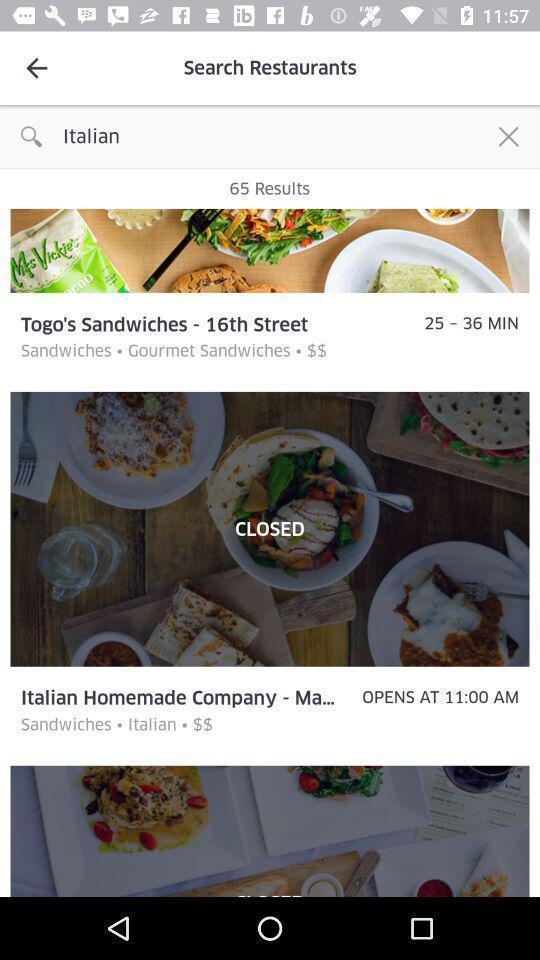Provide a textual representation of this image. Screen showing search on famous restaurants. 